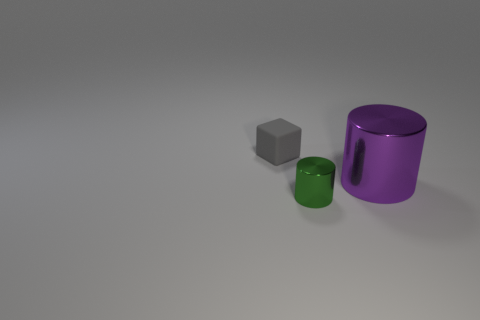How many other large metal cylinders have the same color as the big cylinder?
Provide a short and direct response. 0. Are there any small metal objects?
Provide a succinct answer. Yes. There is a small gray matte thing; is its shape the same as the metallic thing in front of the large shiny cylinder?
Provide a succinct answer. No. What color is the object to the right of the tiny thing that is in front of the object that is to the left of the green metallic cylinder?
Your response must be concise. Purple. Are there any big purple things on the right side of the big purple object?
Provide a short and direct response. No. Are there any other green cylinders made of the same material as the green cylinder?
Your answer should be very brief. No. The matte object is what color?
Ensure brevity in your answer.  Gray. There is a shiny thing that is to the left of the purple shiny cylinder; is it the same shape as the purple thing?
Provide a short and direct response. Yes. There is a shiny thing that is in front of the cylinder behind the small object that is right of the tiny gray object; what is its shape?
Your response must be concise. Cylinder. What is the tiny object that is on the right side of the matte cube made of?
Provide a succinct answer. Metal. 